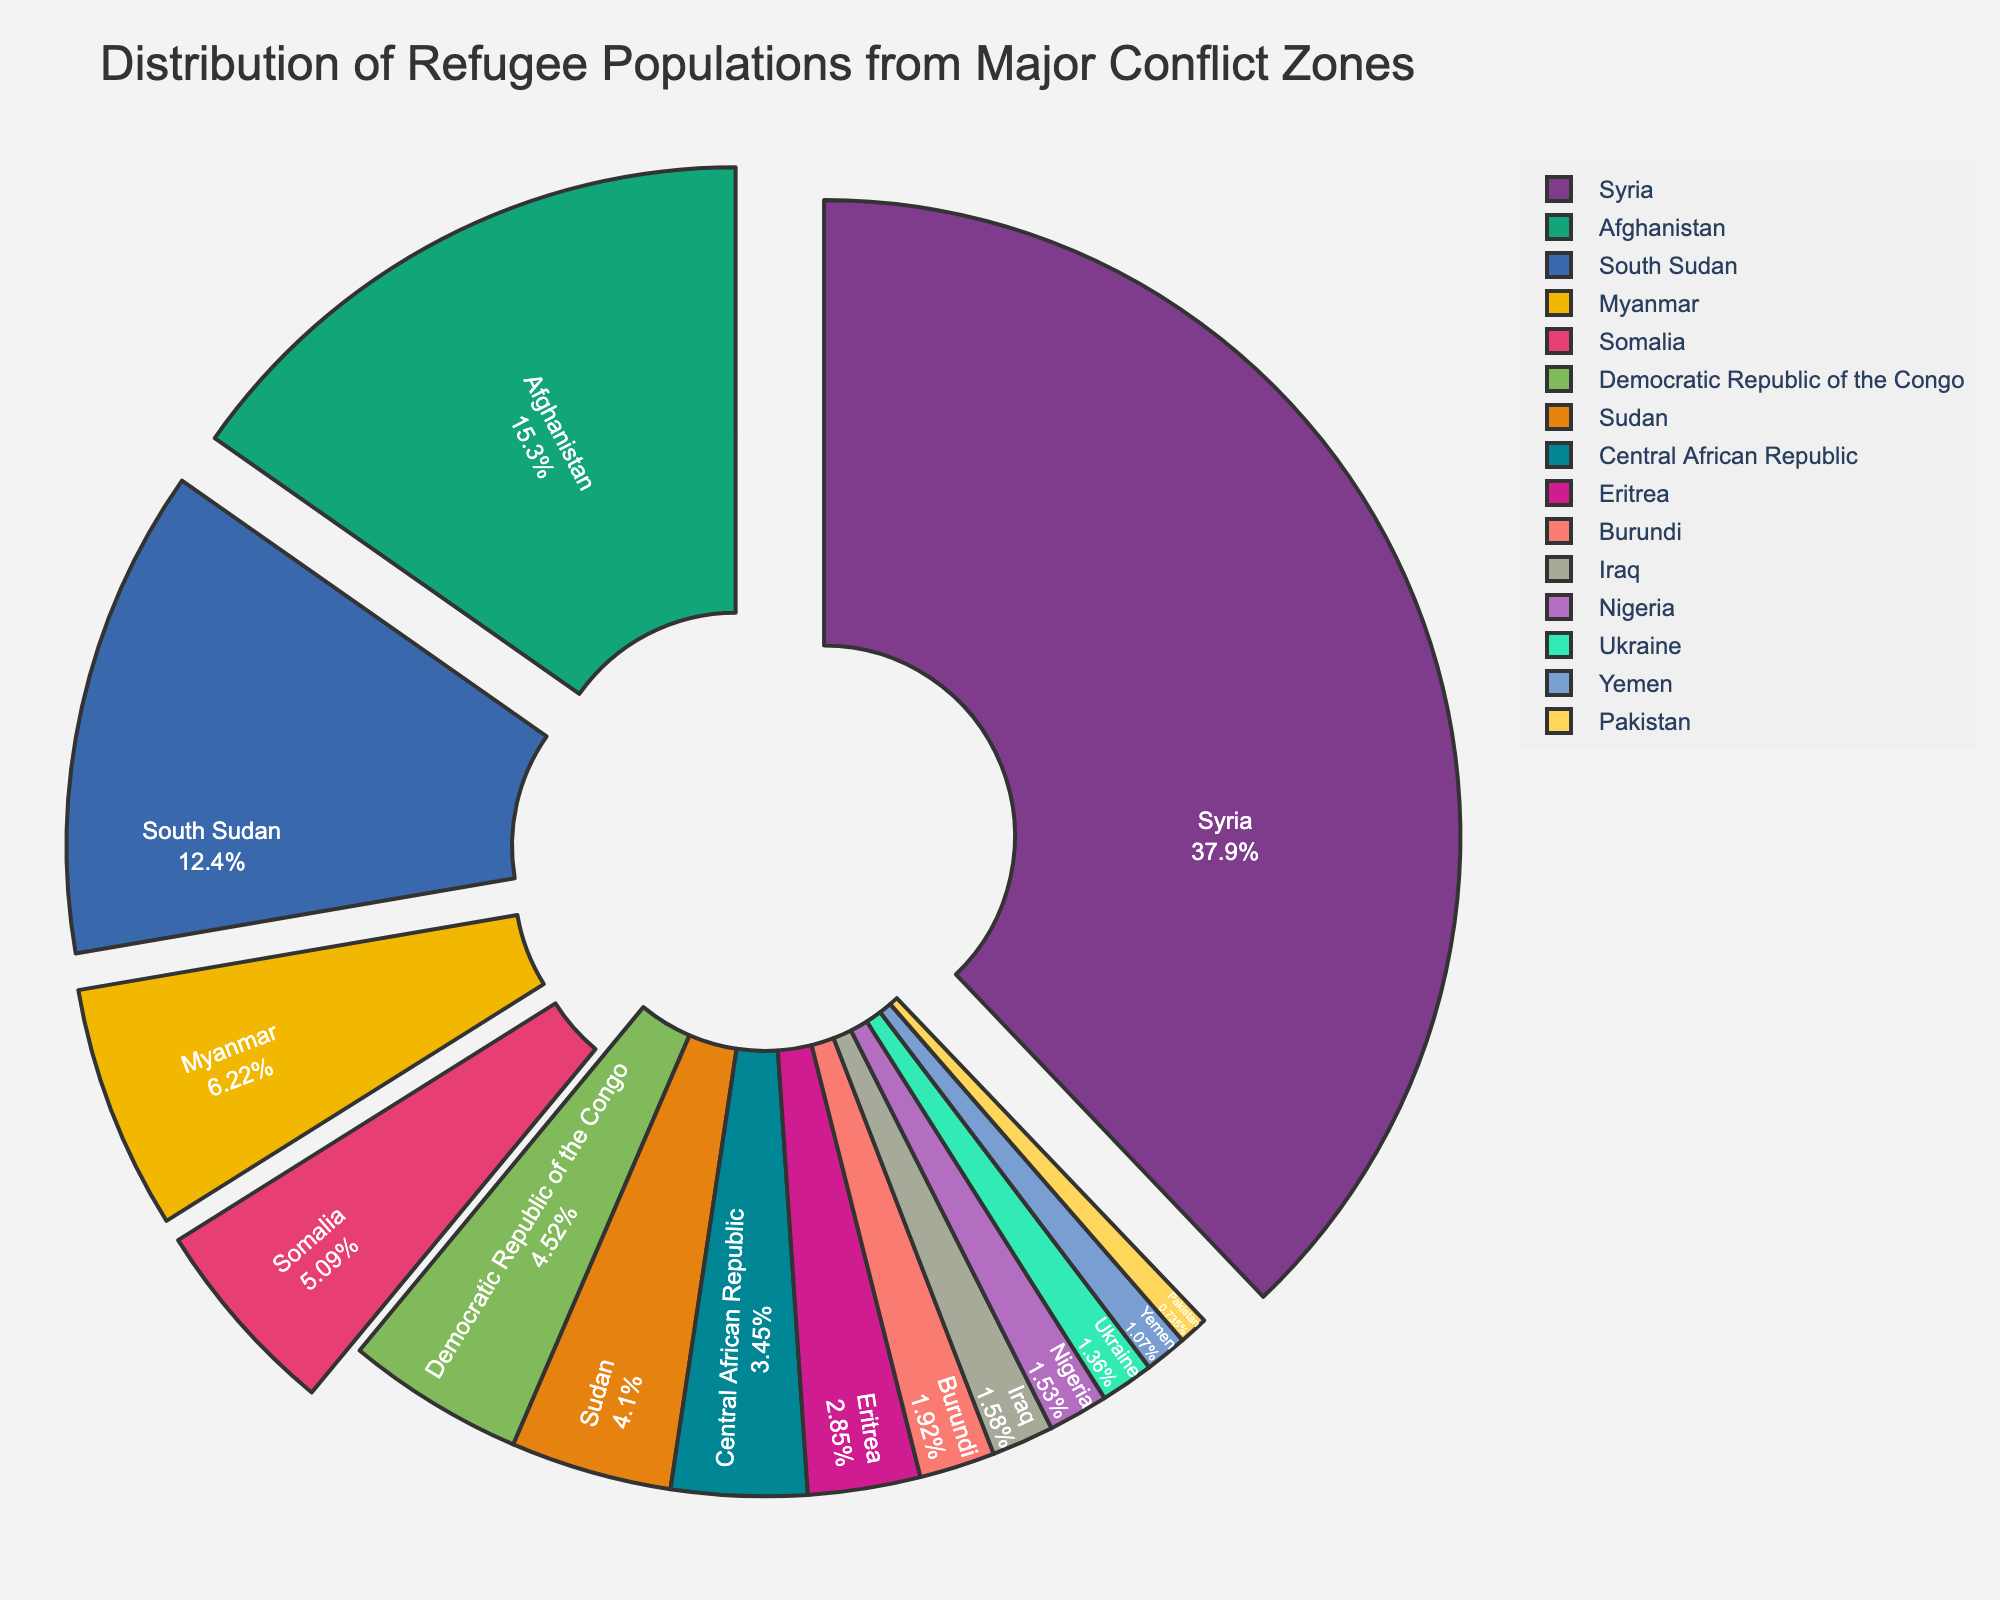Which country has the largest refugee population? By looking at the size and label of the largest segment on the pie chart, we can identify which country has the largest refugee population.
Answer: Syria How does the refugee population of Afghanistan compare to that of South Sudan? Compare the sizes of the segments for Afghanistan and South Sudan to determine which one is larger. Afghanistan's segment appears larger than South Sudan's on the chart.
Answer: Afghanistan has a larger population than South Sudan What percentage of the total refugee population is from Myanmar? The chart provides percentages inside each segment. Locate and read the percentage inside Myanmar’s segment.
Answer: Approximately 6% What is the combined refugee population of the top three countries? The top three countries by refugee population are Syria, Afghanistan, and South Sudan. Sum their populations: 6,700,000 (Syria) + 2,700,000 (Afghanistan) + 2,200,000 (South Sudan) = 11,600,000.
Answer: 11,600,000 Which countries have a refugee population under 300,000? Identify the segments of the pie chart representing less than 300,000 refugees by their smaller size and labels. The countries are Yemen and Pakistan.
Answer: Yemen and Pakistan Is the refugee population of Yemen greater than or less than that of Ukraine? Compare the sizes of the segments for Yemen and Ukraine; Ukraine's segment is larger than Yemen's.
Answer: Less than Which country has a slightly larger refugee population: Somalia or Democratic Republic of the Congo? Compare the sizes of the segments for Somalia and Democratic Republic of the Congo; Somalia's segment is slightly larger than that of Democratic Republic of the Congo.
Answer: Somalia What is the combined percentage of refugees in the chart from Syria, Afghanistan, and Myanmar? Sum the percentages displayed in the chart: Syria (approx. 44%), Afghanistan (approx. 17%), and Myanmar (approx. 6%). Adding these gives 44% + 17% + 6% = 67%.
Answer: 67% Which countries have a refugee population close to 1 million? Check the segments' percentages for populations near 1,000,000. Myanmar and Somalia fit this criterion, with Myanmar showing roughly 1,100,000 and Somalia showing 900,000.
Answer: Myanmar and Somalia What is the refugee population difference between Burundi and Iraq? Identify the populations on the chart and subtract the smaller one from the larger one. Burundi has 340,000 and Iraq has 280,000. The difference is 340,000 - 280,000 = 60,000.
Answer: 60,000 